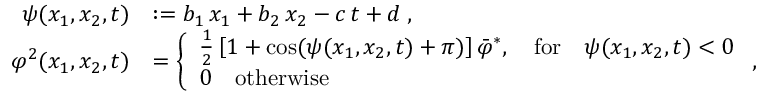<formula> <loc_0><loc_0><loc_500><loc_500>\begin{array} { r l } { \psi ( x _ { 1 } , x _ { 2 } , t ) } & { \colon = b _ { 1 } \, x _ { 1 } + b _ { 2 } \, x _ { 2 } - c \, t + d \, , } \\ { \varphi ^ { 2 } ( x _ { 1 } , x _ { 2 } , t ) } & { = \left \{ \begin{array} { l l } { \frac { 1 } { 2 } \left [ 1 + \cos ( \psi ( x _ { 1 } , x _ { 2 } , t ) + \pi ) \right ] \bar { \varphi } ^ { * } , \quad f o r \quad \psi ( x _ { 1 } , x _ { 2 } , t ) < 0 } \\ { 0 \quad o t h e r w i s e } \end{array} , } \end{array}</formula> 